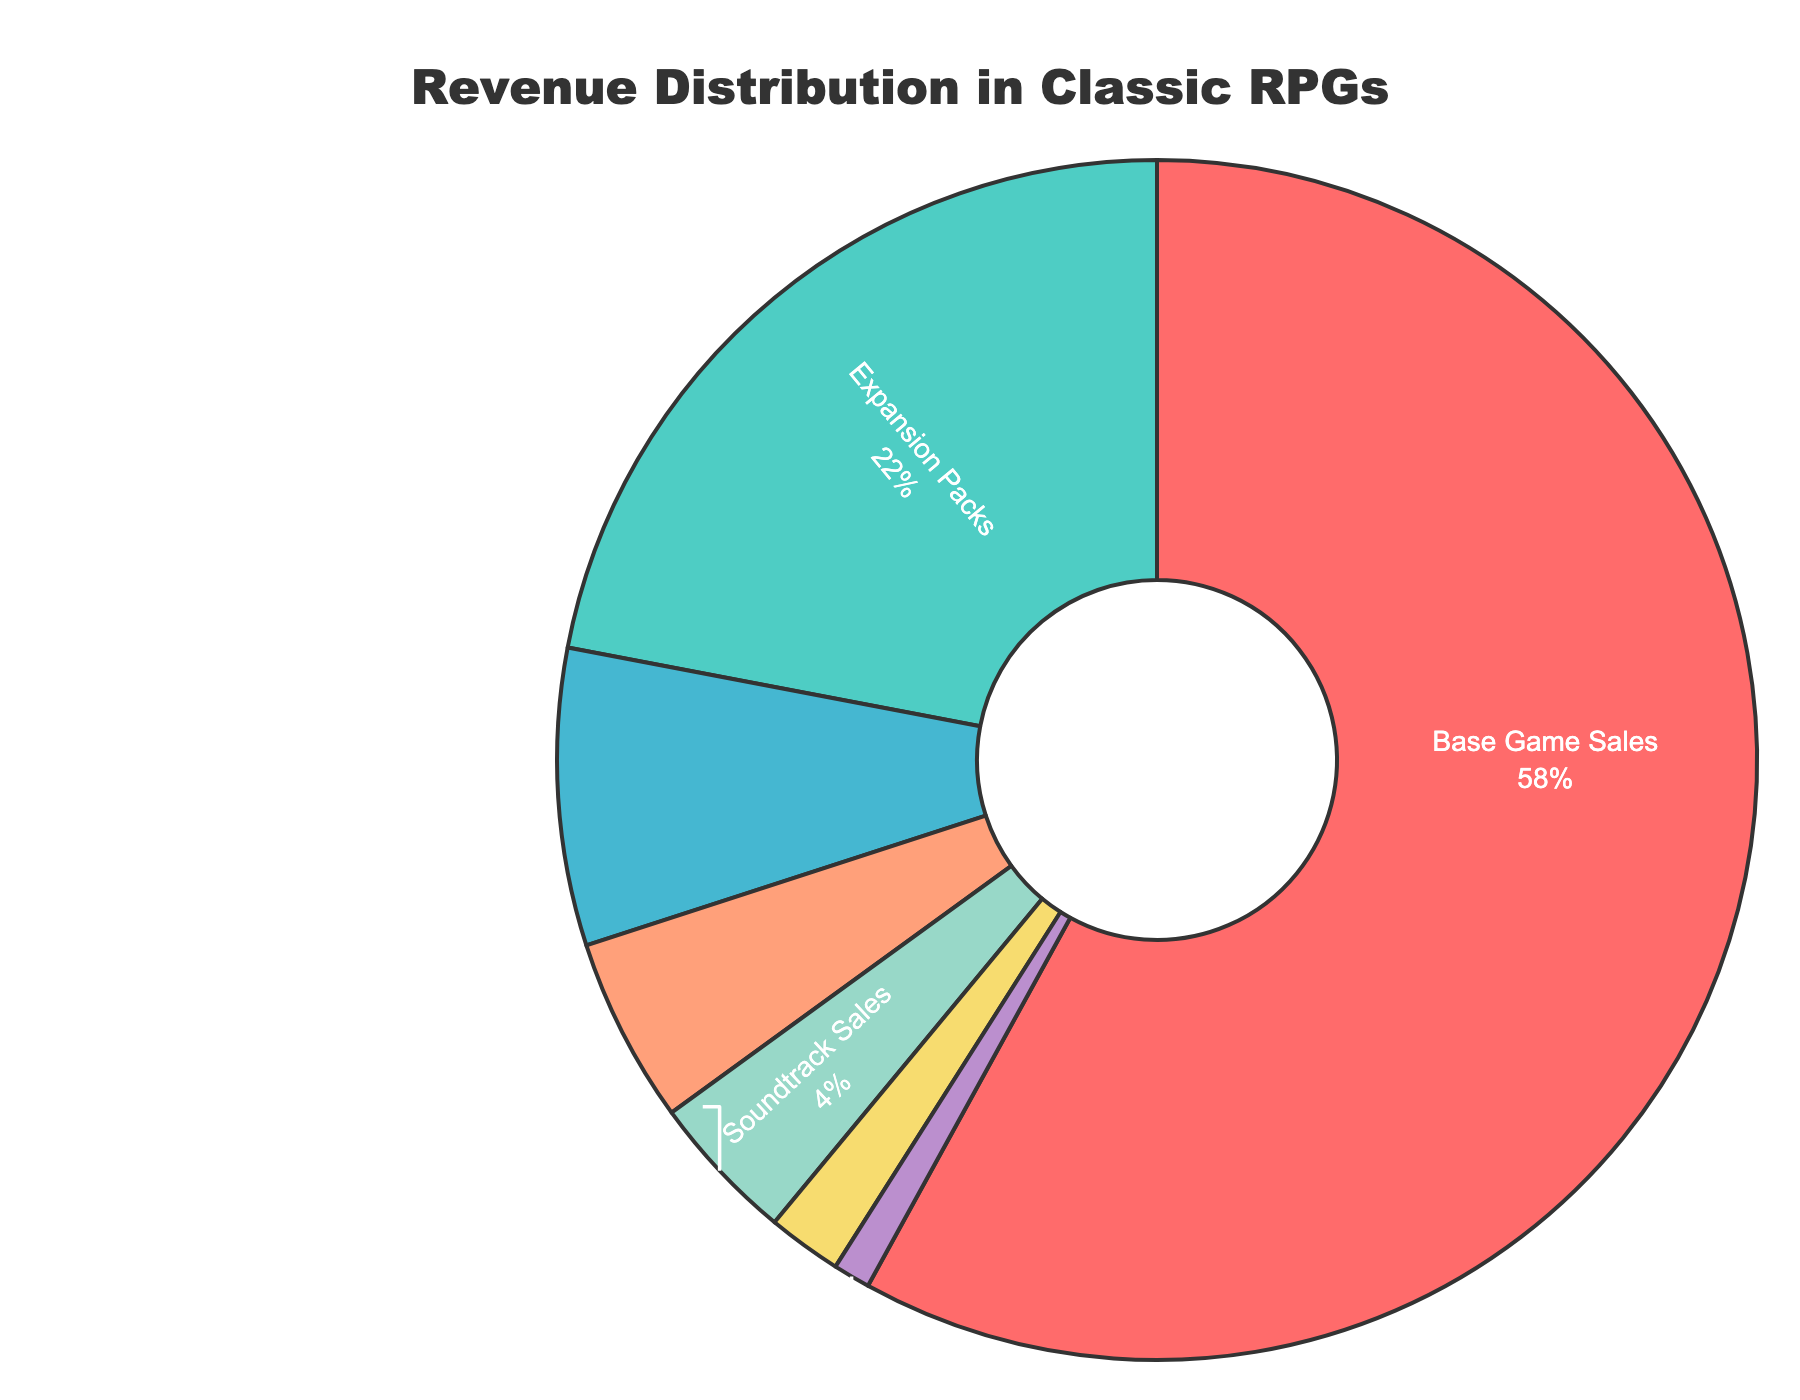What percentage of the total revenue comes from Merchandise (Figurines and Collectibles)? To find this, locate the "Merchandise (Figurines and Collectibles)" section of the pie chart and note the given percentage.
Answer: 8% What's the combined percentage of revenue from Expansion Packs and Soundtrack Sales? Add the percentages of "Expansion Packs" and "Soundtrack Sales" together: 22% + 4% = 26%.
Answer: 26% Which category contributes the least to the total revenue? Identify the section of the pie chart with the smallest percentage. Here, it's "Tabletop Adaptations" with 1%.
Answer: Tabletop Adaptations How does the revenue from Base Game Sales compare to the revenue from Strategy Guides and Art Books? The percentage for "Base Game Sales" is 58%, while for "Strategy Guides and Art Books" it's 5%. 58% is much greater than 5%.
Answer: Base Game Sales is much higher If Expansion Packs and Digital Deluxe Editions were combined into one category, would it surpass Base Game Sales in terms of revenue percentage? Sum the percentages of "Expansion Packs" and "Digital Deluxe Editions": 22% + 2% = 24%. Compare this sum to "Base Game Sales" which is 58%. 24% is less than 58%, so it would not surpass.
Answer: No What is the difference in revenue percentages between the highest and the lowest contributing categories? Identify the highest percentage ("Base Game Sales" - 58%) and the lowest percentage ("Tabletop Adaptations" - 1%). Subtract the lowest from the highest: 58% - 1% = 57%.
Answer: 57% Which categories together contribute the same percentage of revenue as Strategy Guides and Art Books and Soundtrack Sales combined? First, combine "Strategy Guides and Art Books" (5%) and "Soundtrack Sales" (4%): 5% + 4% = 9%. Look for categories whose total equals 9%. Here, "Merchandise (Figurines and Collectibles)" (8%) and "Tabletop Adaptations" (1%) together make up 9%.
Answer: Merchandise (Figurines and Collectibles) and Tabletop Adaptations Which category uses the green segment in the pie chart, and what is its percentage? Identify the green segment in the pie chart, which represents "Expansion Packs" at 22%.
Answer: Expansion Packs, 22% Is the total revenue percentage from digital-related sources (Base Game Sales, Digital Deluxe Editions, and Soundtrack Sales) more than 60%? Sum the percentages of "Base Game Sales" (58%), "Digital Deluxe Editions" (2%), and "Soundtrack Sales" (4%): 58% + 2% + 4% = 64%. 64% is more than 60%.
Answer: Yes 